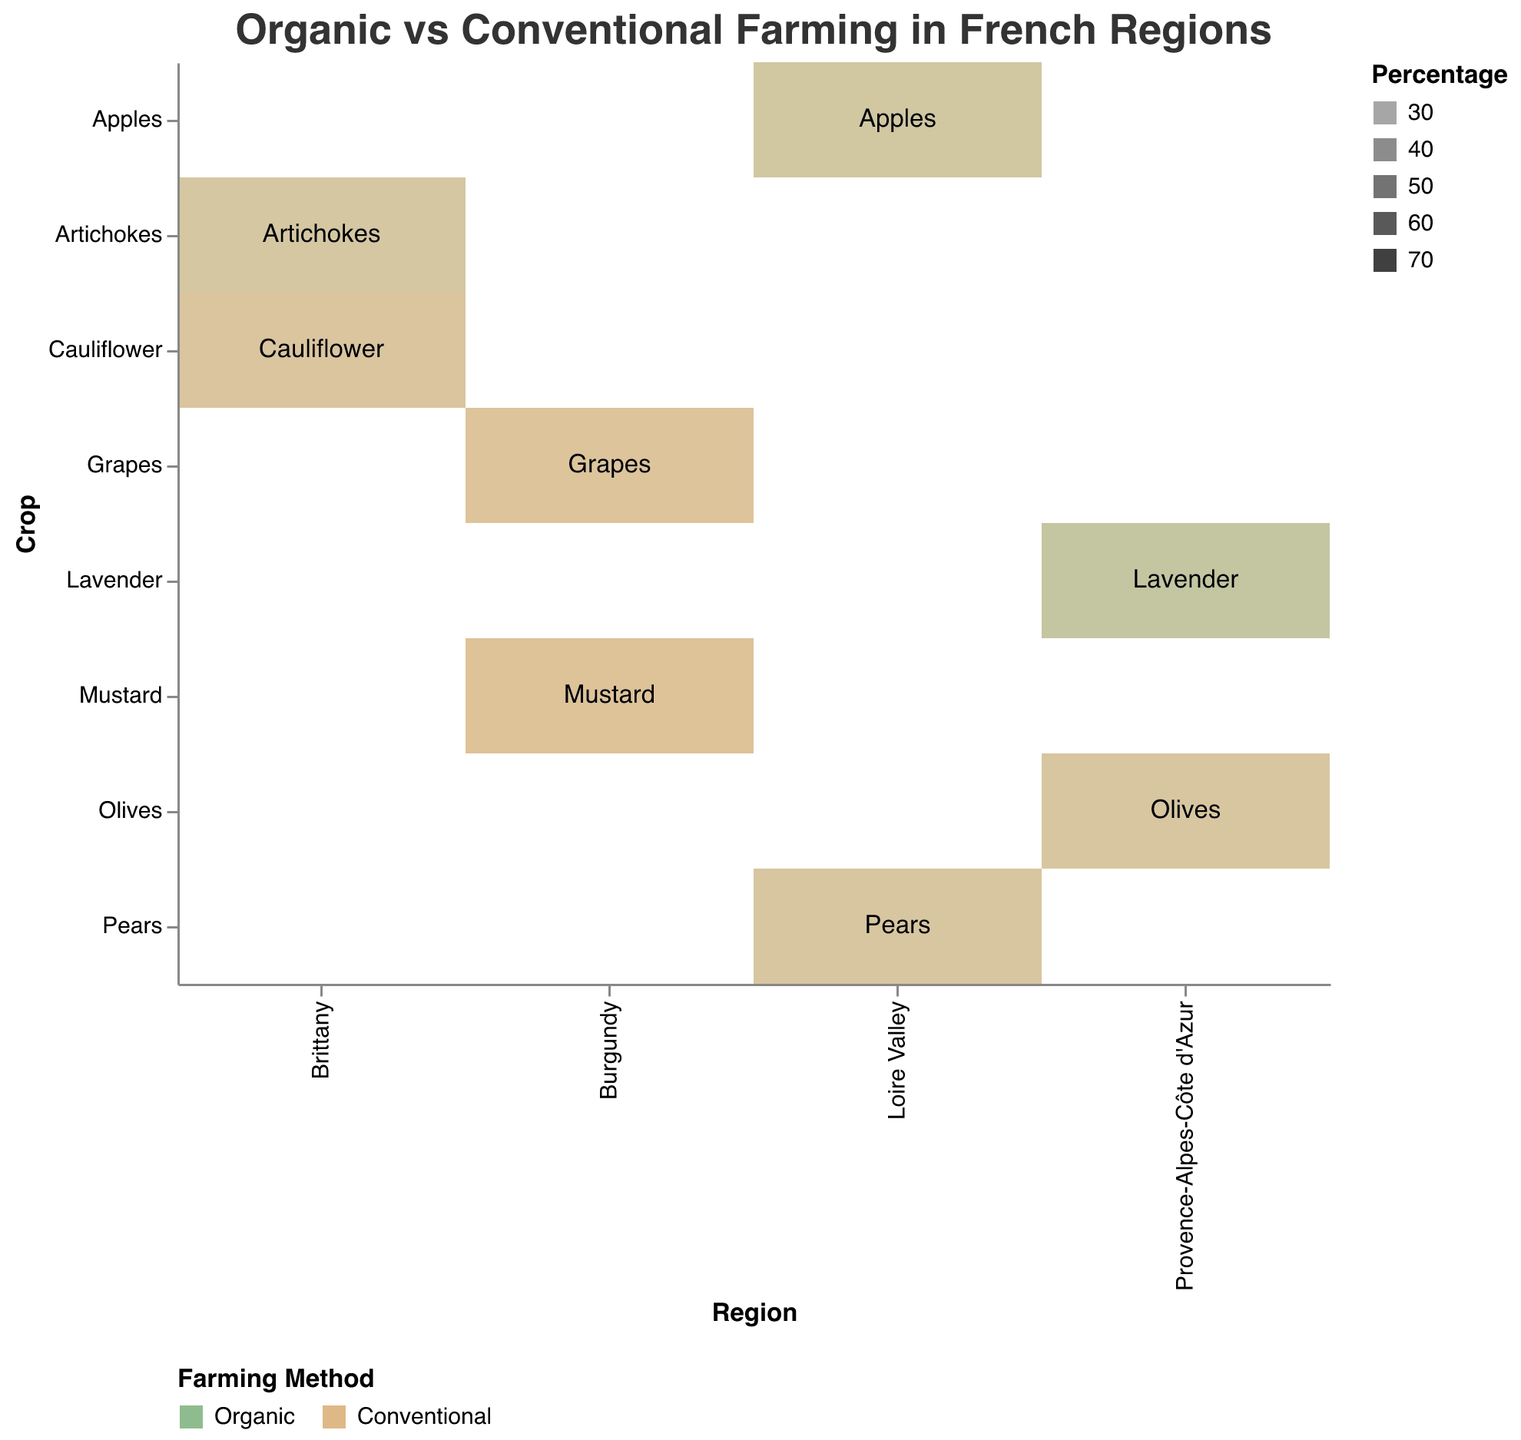What is the title of the figure? The title is typically placed at the top of the figure and is used to describe the central theme or subject of the visualization.
Answer: Organic vs Conventional Farming in French Regions Which region has the highest percentage of organic farming for Lavender? By examining the rectangles colored for Lavender and checking the opacity representing the percentage, we can identify the highest percentage for organic farming. Provence-Alpes-Côte d'Azur has Lavender with 65% organic farming.
Answer: Provence-Alpes-Côte d'Azur What percentage of Grapes in Burgundy is farmed using conventional methods? Locate the region Burgundy and the crop Grapes in the grid and identify the rectangle representing conventional farming. The tooltip or opacity indicates the percentage.
Answer: 70% Compare the percentage of organic farming for Olives in Provence-Alpes-Côte d'Azur to Pears in Loire Valley. Which is higher? Locate the rectangles representing Olives in Provence-Alpes-Côte d'Azur and Pears in Loire Valley, then compare their organic farming percentages using the tooltip or opacity level. Olives have 40% and Pears have 40%, so they are equal.
Answer: Equal Which crop has equal proportions of organic and conventional farming in its region? Search through the figure where the rectangles for a crop in a region are both semi-transparent (50% opacity), indicating equal divisions. Apples in Loire Valley show this pattern.
Answer: Apples Is the percentage of conventional farming higher for Mustard in Burgundy or Cauliflower in Brittany? Locate the regions and crops on the grid, then identify the percentage of conventional farming by observing the opacity of the rectangles. Mustard in Burgundy has 75% while Cauliflower in Brittany has 65%, thus Mustard is higher.
Answer: Mustard in Burgundy What's the average percentage of organic farming for crops in Brittany? Identify the organic farming percentages for Artichokes and Cauliflower in Brittany (45% and 35%) and calculate their average: (45 + 35) / 2 = 40%.
Answer: 40% Which crop has the least proportion of organic farming in Burgundy? Locate Burgundy on the grid, then find the crop with the least intense green color representing organic farming percentage. Mustard in Burgundy has the lowest with 25%.
Answer: Mustard How does the percentage of organic Artichokes in Brittany compare to that of Lavender in Provence-Alpes-Côte d'Azur? Compare the opacity of the rectangles representing organic Artichokes in Brittany and Lavender in Provence-Alpes-Côte d'Azur. Artichokes have 45% and Lavender has 65%, thus Lavender is higher.
Answer: Lavender in Provence-Alpes-Côte d'Azur 